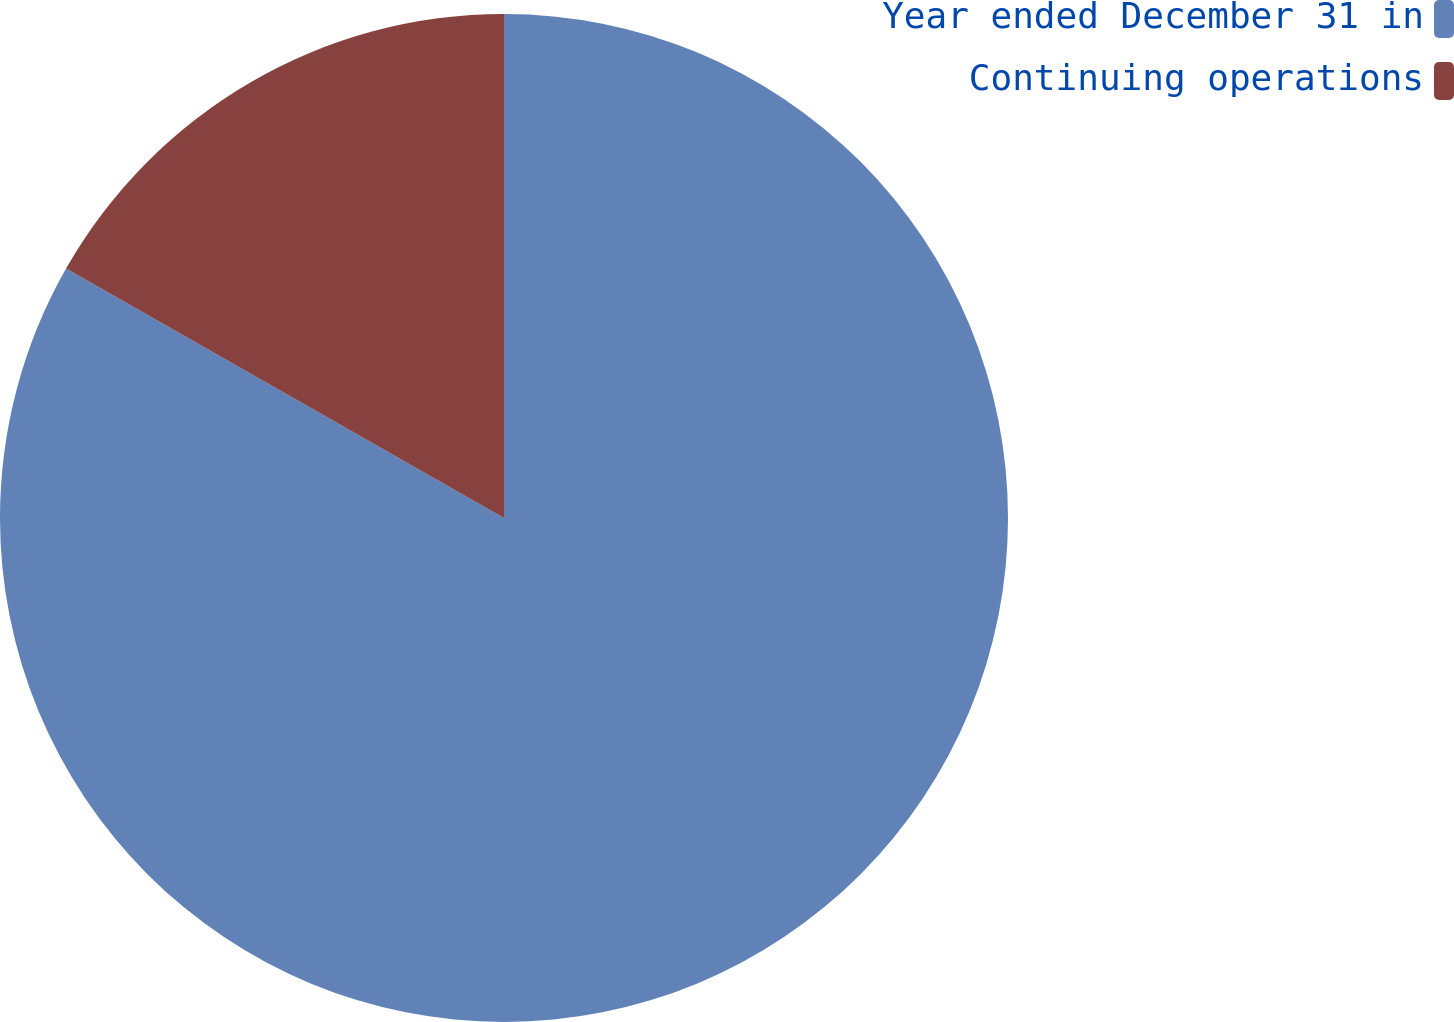<chart> <loc_0><loc_0><loc_500><loc_500><pie_chart><fcel>Year ended December 31 in<fcel>Continuing operations<nl><fcel>83.24%<fcel>16.76%<nl></chart> 